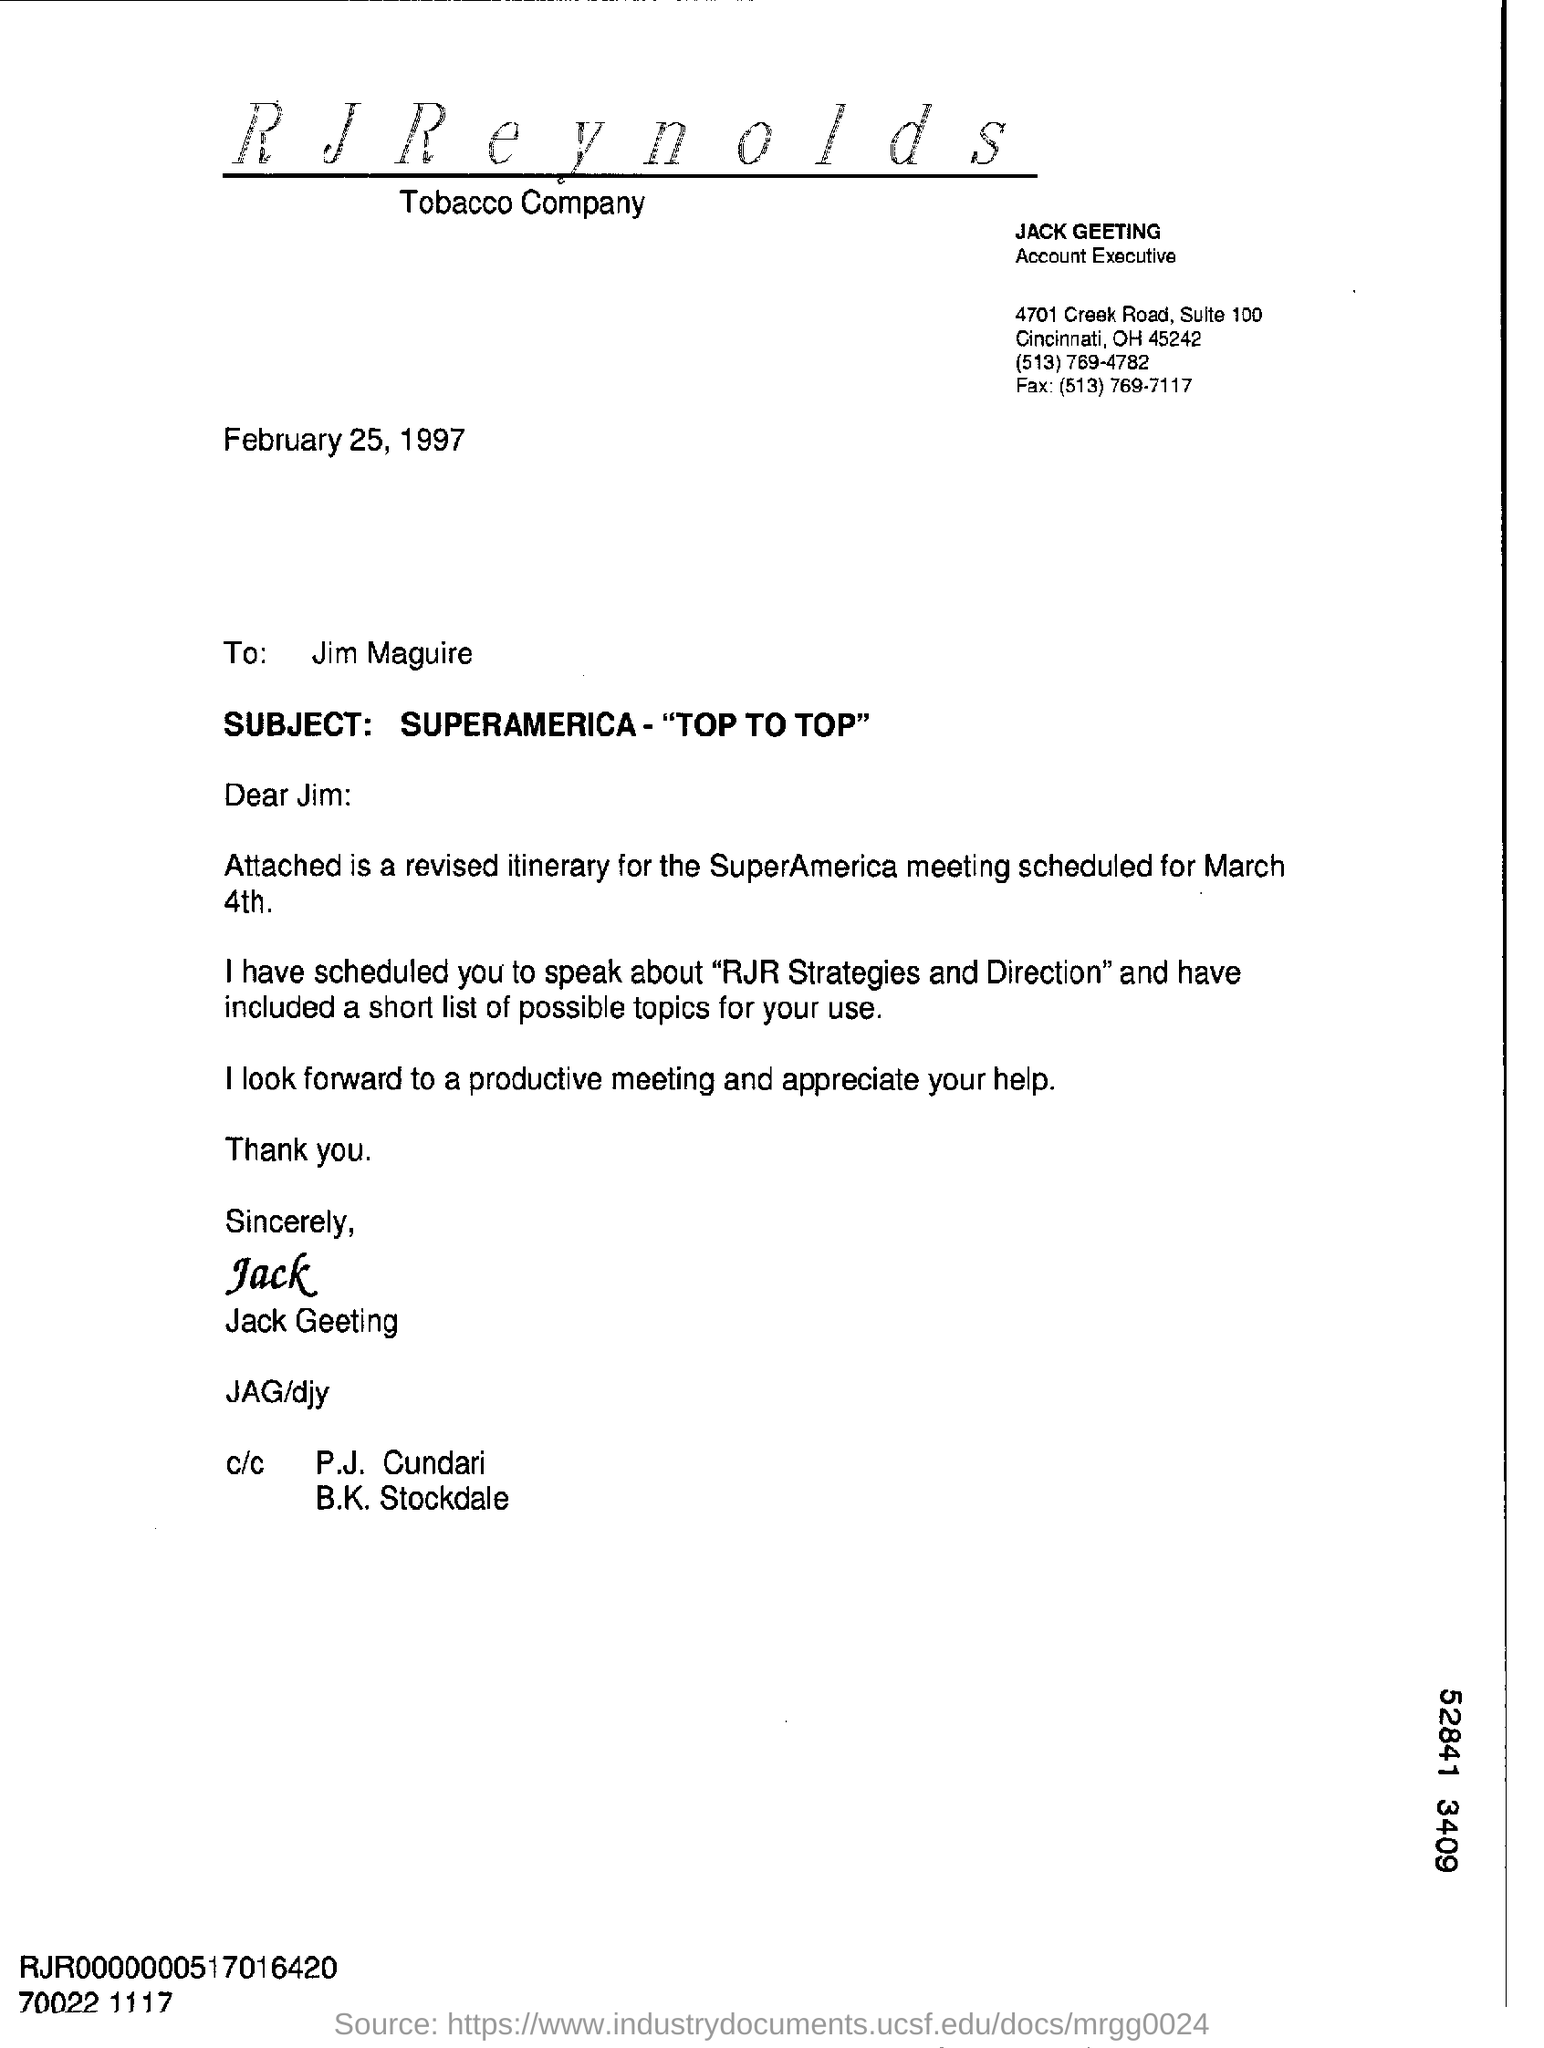Outline some significant characteristics in this image. Can you please provide me with the suite number of the company? Jack Greeting's designation is Account Executive. The subject of this letter is "Superamerica- "Top to Top"..". The attached document is a revised itinerary for the SuperAmerica meeting scheduled for March 4th. The date on which this document is sent is February 25, 1997. 